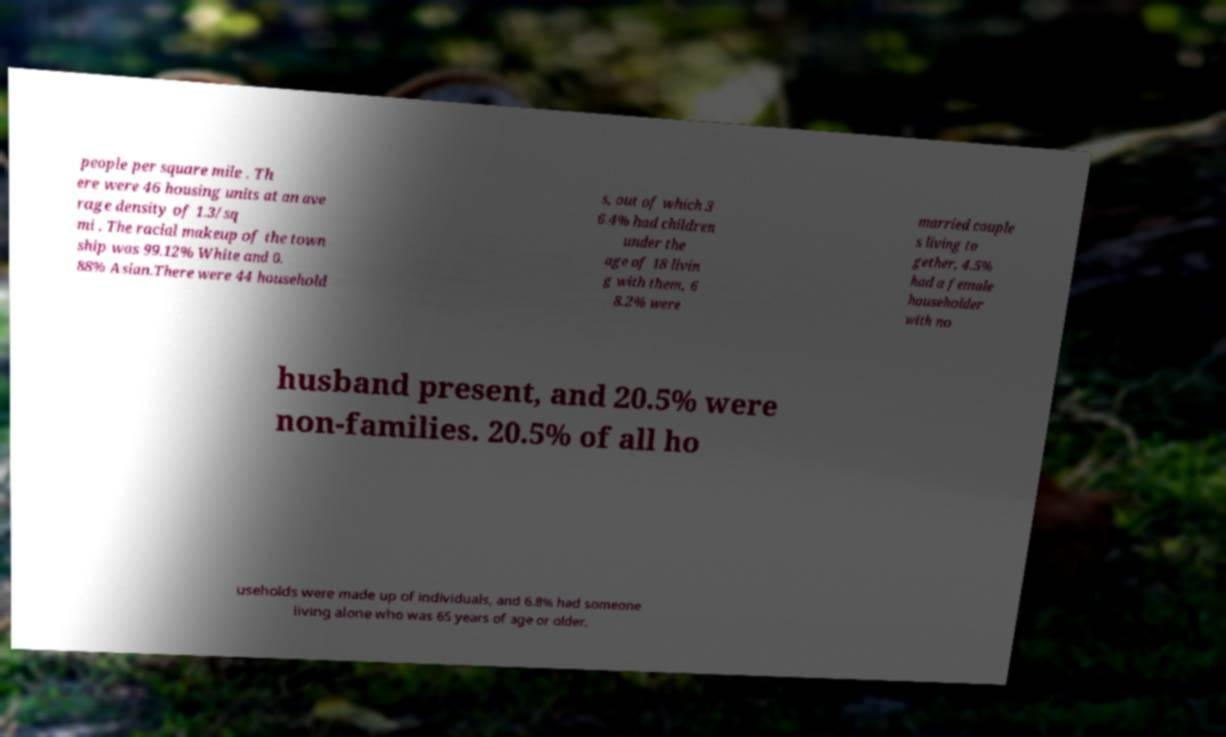I need the written content from this picture converted into text. Can you do that? people per square mile . Th ere were 46 housing units at an ave rage density of 1.3/sq mi . The racial makeup of the town ship was 99.12% White and 0. 88% Asian.There were 44 household s, out of which 3 6.4% had children under the age of 18 livin g with them, 6 8.2% were married couple s living to gether, 4.5% had a female householder with no husband present, and 20.5% were non-families. 20.5% of all ho useholds were made up of individuals, and 6.8% had someone living alone who was 65 years of age or older. 